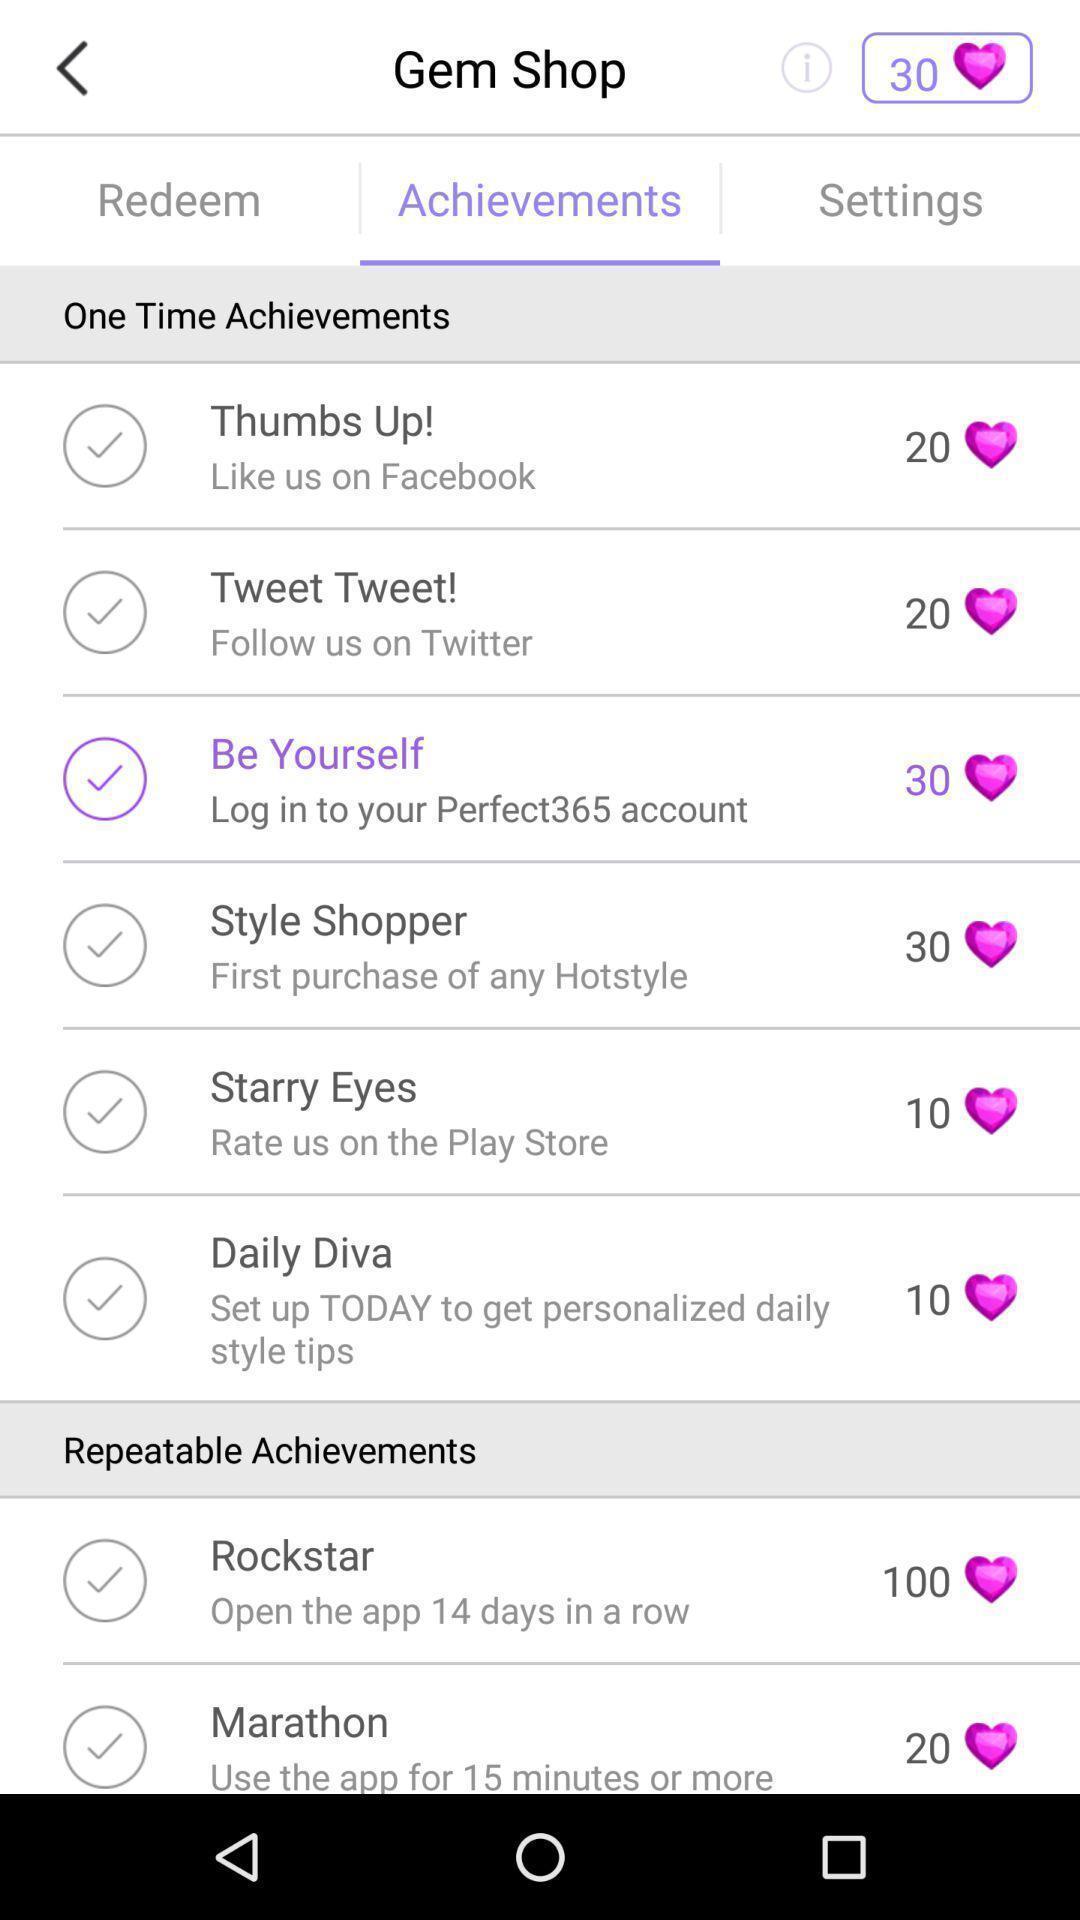Provide a textual representation of this image. Page displays list of achievements in app. 